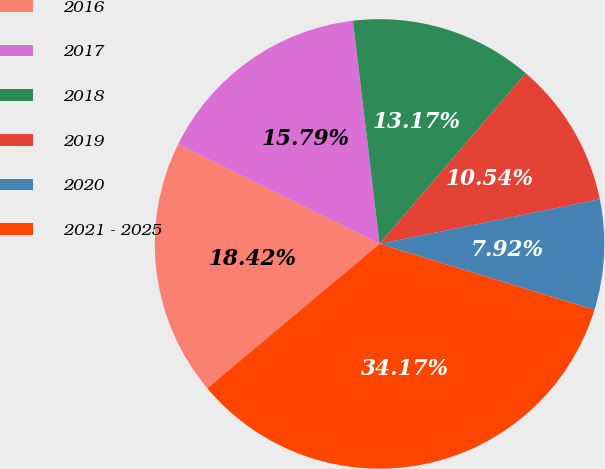<chart> <loc_0><loc_0><loc_500><loc_500><pie_chart><fcel>2016<fcel>2017<fcel>2018<fcel>2019<fcel>2020<fcel>2021 - 2025<nl><fcel>18.42%<fcel>15.79%<fcel>13.17%<fcel>10.54%<fcel>7.92%<fcel>34.17%<nl></chart> 